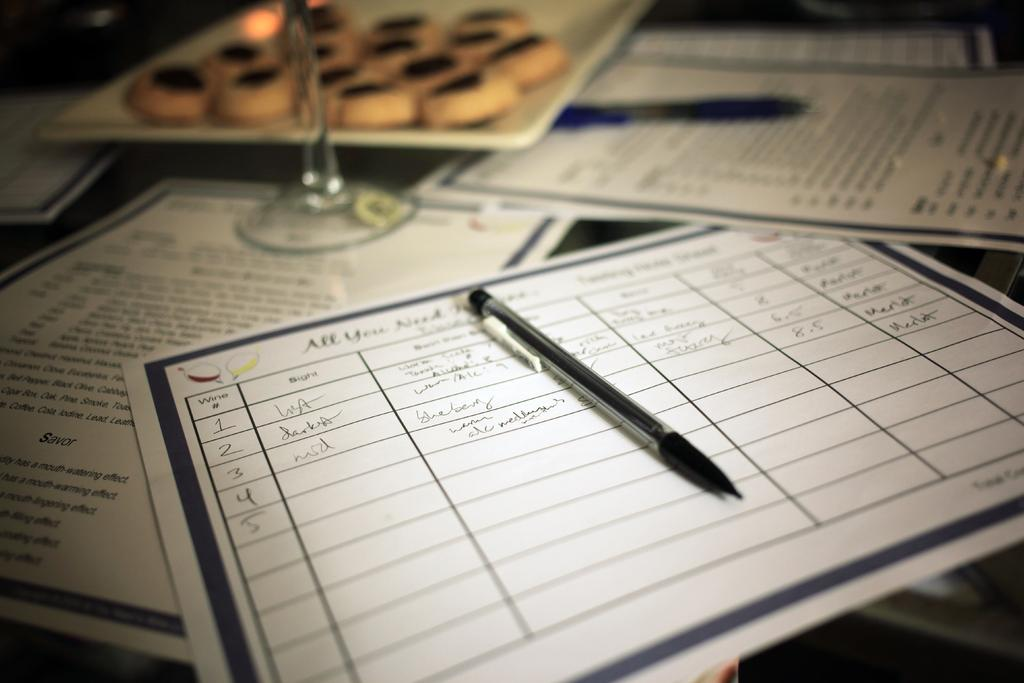What type of objects can be seen on the table in the image? There are papers, a pen, and a glass on the table in the image. What might be used for writing in the image? The pen in the image can be used for writing. What is the purpose of the glass in the image? The purpose of the glass in the image is not clear, but it could be used for holding a drink or other liquid. What type of harbor can be seen in the image? There is no harbor present in the image; it only contains papers, a pen, and a glass on a table. What idea is being expressed by the papers in the image? The image does not provide any information about the content or idea being expressed by the papers, so it cannot be determined from the image. 